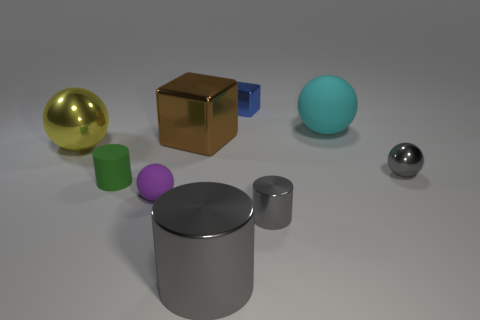Do the rubber sphere that is to the left of the big cyan ball and the cube in front of the cyan rubber thing have the same size?
Make the answer very short. No. Is there a thing that is behind the large metallic object that is in front of the green object that is on the left side of the tiny purple ball?
Your answer should be very brief. Yes. Is the number of tiny green matte cylinders that are to the left of the rubber cylinder less than the number of things that are behind the tiny purple rubber thing?
Your answer should be very brief. Yes. What is the shape of the tiny blue thing that is made of the same material as the brown cube?
Give a very brief answer. Cube. There is a ball in front of the small green cylinder in front of the object on the left side of the tiny rubber cylinder; what size is it?
Your answer should be very brief. Small. Are there more big gray shiny objects than small green spheres?
Keep it short and to the point. Yes. There is a object that is to the left of the green object; is its color the same as the small thing behind the yellow shiny sphere?
Offer a very short reply. No. Do the big sphere that is on the left side of the small gray metallic cylinder and the tiny cylinder left of the brown metallic object have the same material?
Provide a short and direct response. No. What number of yellow shiny objects are the same size as the cyan thing?
Ensure brevity in your answer.  1. Is the number of tiny gray cylinders less than the number of balls?
Make the answer very short. Yes. 